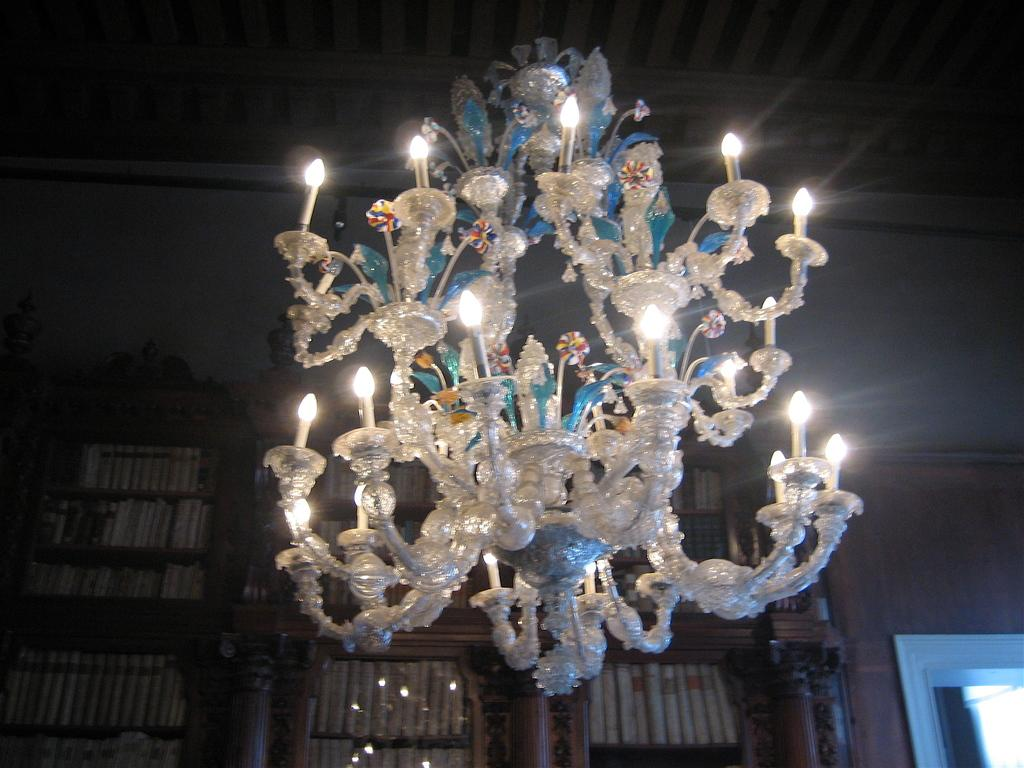What is hanging from the ceiling in the image? There is a chandelier attached to the ceiling in the image. What can be seen inside the cupboards in the image? There are objects in cupboards in the image. What is visible on the sides or background of the image? There is a wall visible in the image. How many soldiers are present in the image? There is no army or soldiers present in the image. What type of face can be seen on the wall in the image? There is no face visible on the wall in the image. 